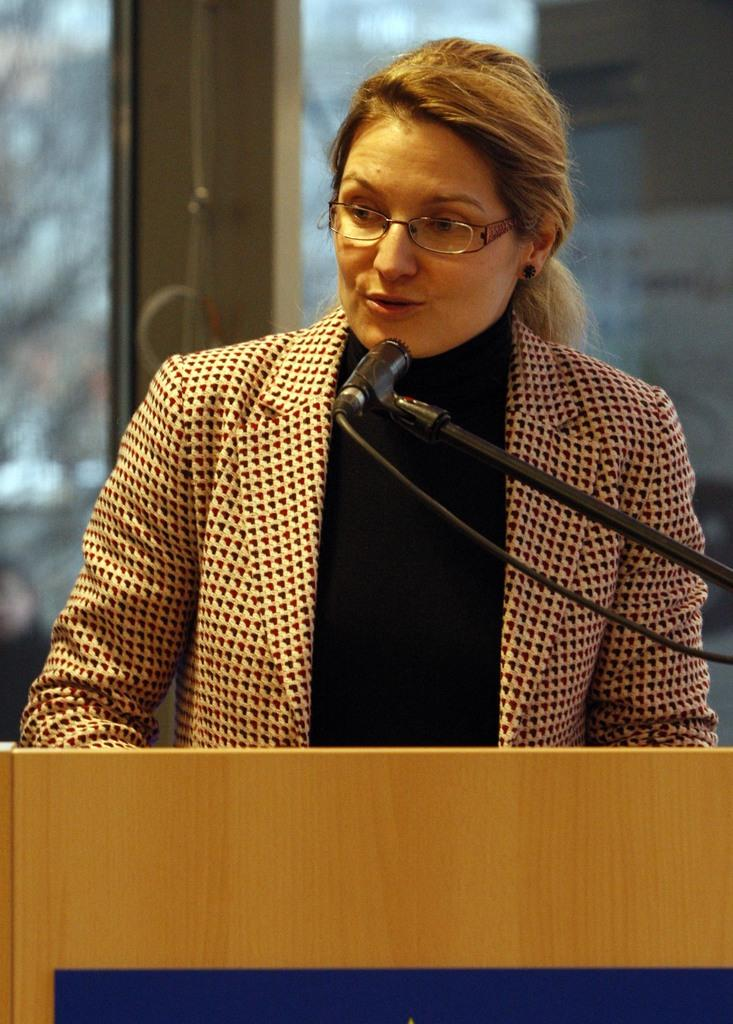What is the woman in the image doing? The woman is standing at a podium in the image. What is the woman likely using to amplify her voice? There is a microphone on a stand in the image, which the woman might be using. What can be seen in the background of the image? There are glass doors in the background of the image. What is visible through the glass doors? Objects are visible through the glass doors. Where are the kittens playing in the image? There are no kittens present in the image. 